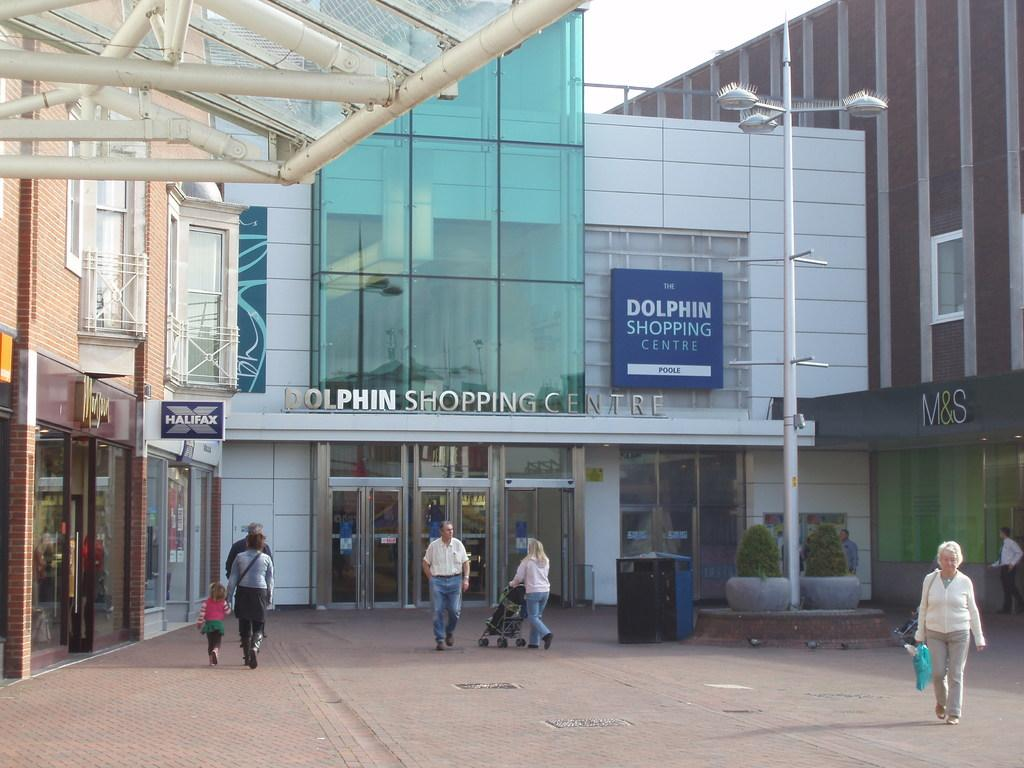How many people are in the image? There are many people in the image. What are the people wearing? The people are wearing clothes. What are the people doing in the image? The people are walking. What type of path can be seen in the image? There is a footpath in the image. What structure is present in the image? There is a light pole in the image. What type of building is visible in the image? There is a building in the image. What part of the building can be seen in the image? There is a roof in the image. What type of barrier is present in the image? There is a fence in the image. What type of text can be seen in the image? There is text in the image. What type of board is visible in the image? There is a board in the image. What type of vegetation is present in the image? There are plants in the image. What is the color of the sky in the image? The sky is white in the image. How many family members are smiling in the image? There is no information about family members or smiling in the image. What type of fowl can be seen walking on the footpath in the image? There is no fowl present in the image. 